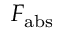Convert formula to latex. <formula><loc_0><loc_0><loc_500><loc_500>F _ { a b s }</formula> 